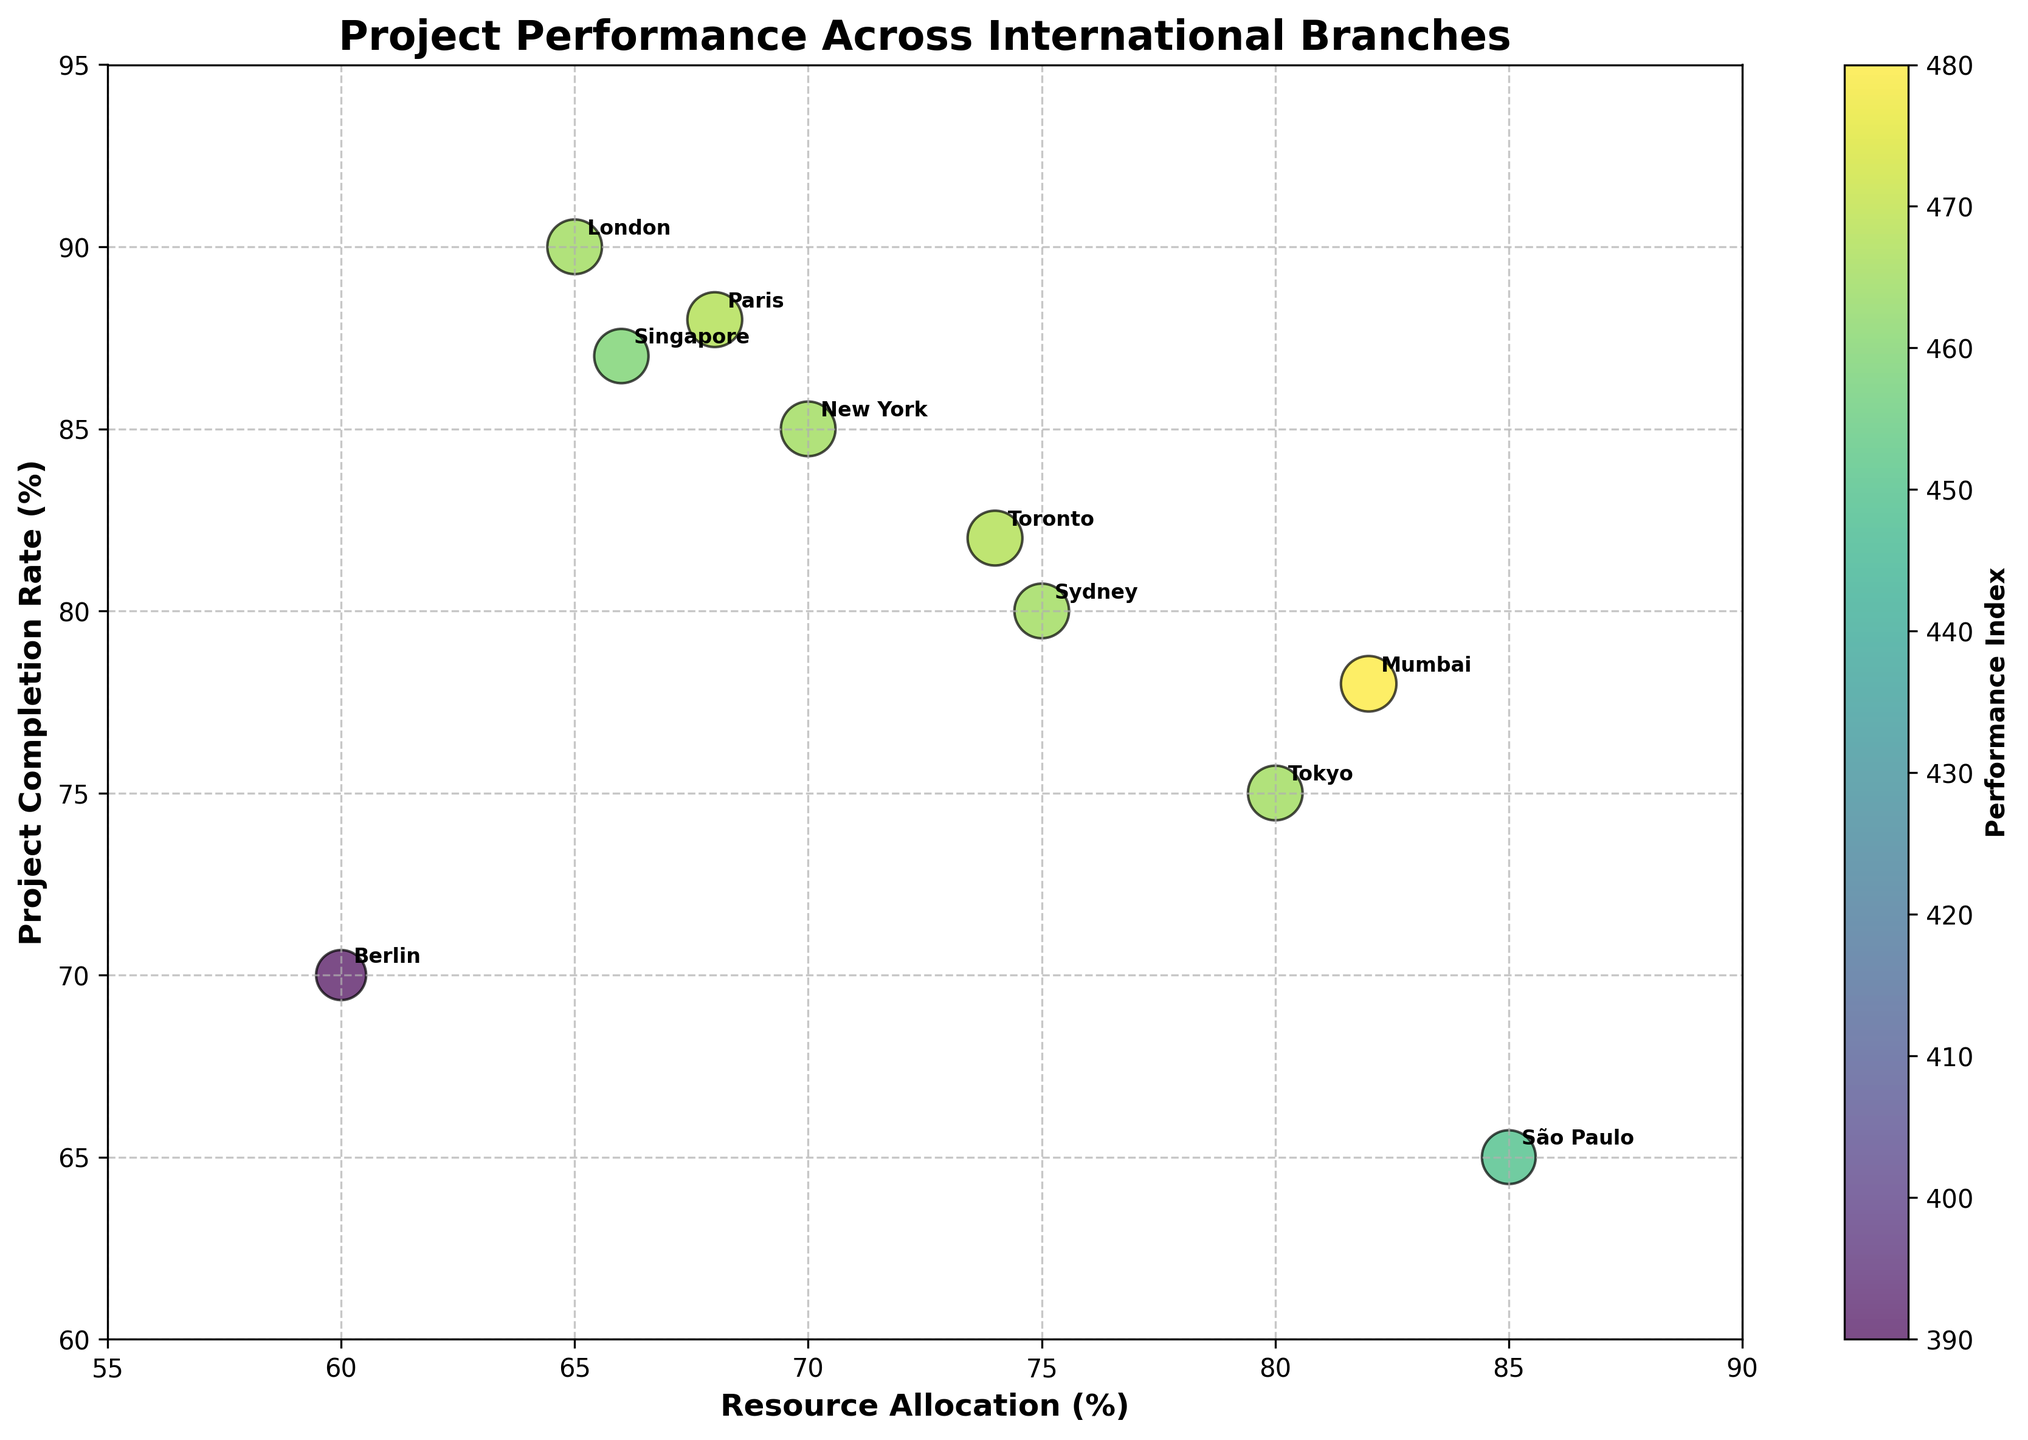What is the title of the figure? The title of the figure is displayed at the top center of the chart and is meant to summarize what the chart represents.
Answer: Project Performance Across International Branches Which branch has the highest project completion rate? Observing the y-axis for the highest value, the point labeled 'London' is at 90%, the highest value on the chart.
Answer: London What is the range of resource allocation percentages displayed on the chart? The x-axis shows resource allocations ranging from 55% to 90%.
Answer: 55% to 90% Which branches have resource allocations above 80%? Looking along the x-axis, branches with resource allocations above 80% are Tokyo, São Paulo, and Mumbai.
Answer: Tokyo, São Paulo, Mumbai How does the completion rate of New York compare to that of Toronto? On the y-axis, the completion rate of New York (85%) is slightly higher than that of Toronto (82%).
Answer: New York's rate is higher What is the average project completion rate for the branches shown? Sum all the completion rates (85+90+75+80+70+65+88+78+82+87) = 800. Since there are 10 branches, the average is 800/10 = 80%.
Answer: 80% Which branch has the largest bubble, and what does it signify? The largest bubble indicates the highest combined value of resource allocation and project completion rate. The branch São Paulo stands out with the largest bubble.
Answer: São Paulo What is the unique feature of the color of each bubble in the chart? Each bubble’s color is determined by its performance index, a combination of resource allocation and project completion rate, indicated by the color bar scaling from dark to light shades.
Answer: Performance index-based color Which branch has the highest resource allocation percentage but a relatively lower project completion rate? Comparing the x-axis (resource allocation) and y-axis (completion rate), São Paulo has the highest allocation (85%) but a lower completion rate (65%).
Answer: São Paulo For which branch can you find a near-equal level of resource allocation and project completion rate? The branch Tokyo has a resource allocation of 80% and a project completion rate of 75%, which are relatively close values.
Answer: Tokyo 